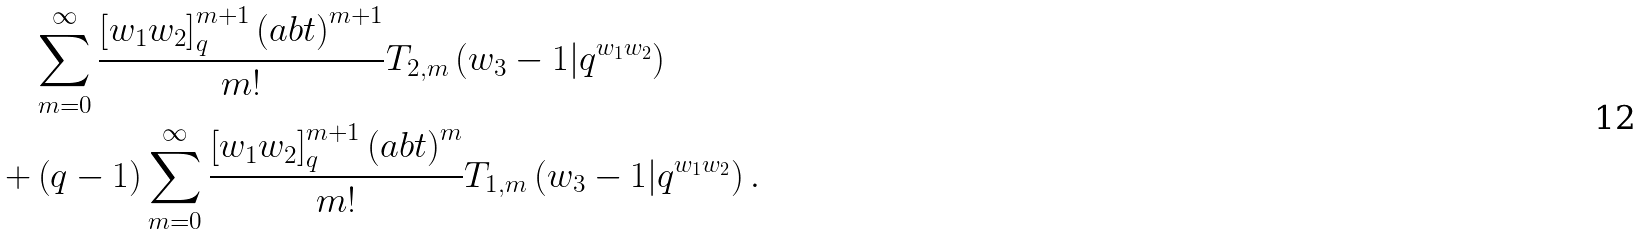Convert formula to latex. <formula><loc_0><loc_0><loc_500><loc_500>& \sum _ { m = 0 } ^ { \infty } \frac { \left [ w _ { 1 } w _ { 2 } \right ] _ { q } ^ { m + 1 } \left ( a b t \right ) ^ { m + 1 } } { m ! } T _ { 2 , m } \left ( w _ { 3 } - 1 | q ^ { w _ { 1 } w _ { 2 } } \right ) \\ + & \left ( q - 1 \right ) \sum _ { m = 0 } ^ { \infty } \frac { \left [ w _ { 1 } w _ { 2 } \right ] _ { q } ^ { m + 1 } \left ( a b t \right ) ^ { m } } { m ! } T _ { 1 , m } \left ( w _ { 3 } - 1 | q ^ { w _ { 1 } w _ { 2 } } \right ) .</formula> 